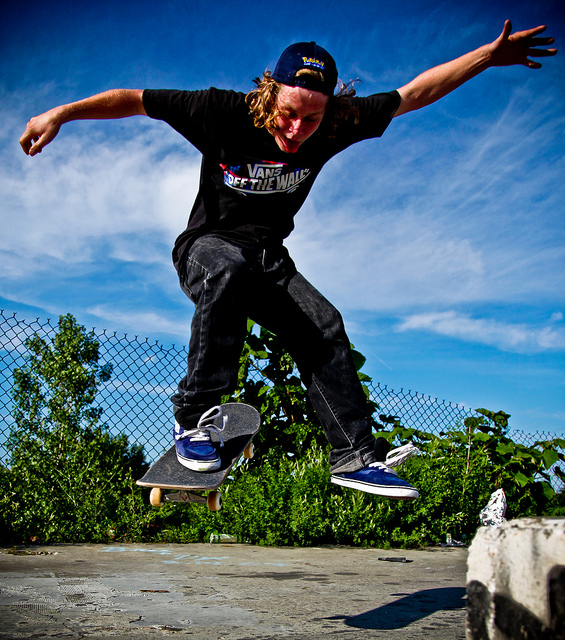<image>What does his skateboard say? It is not certain what the skateboard says. It could say 'Nike', 'Natas', or 'Stop'. On which wrist is the man wearing something? The man is not wearing anything on either wrist. What does his skateboard say? I don't know what his skateboard says. It can be nothing or it can be 'nike', 'natas', 'stop' or something else. On which wrist is the man wearing something? I don't know on which wrist the man is wearing something. He is not wearing anything on either wrist. 